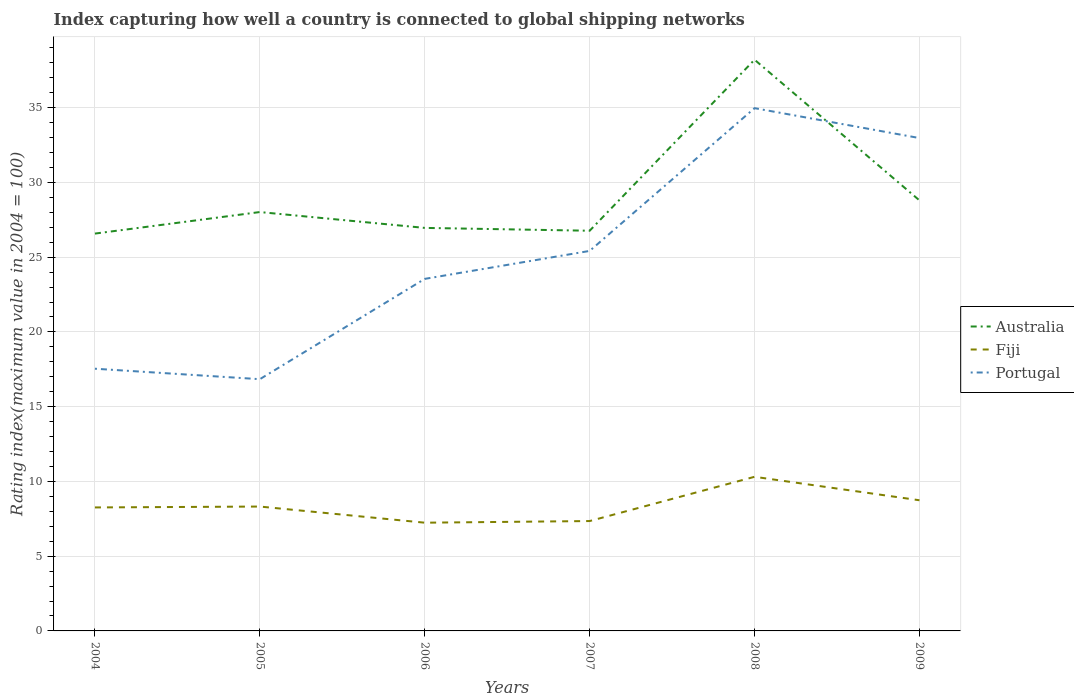Does the line corresponding to Australia intersect with the line corresponding to Portugal?
Give a very brief answer. Yes. Is the number of lines equal to the number of legend labels?
Keep it short and to the point. Yes. Across all years, what is the maximum rating index in Australia?
Provide a succinct answer. 26.58. What is the total rating index in Portugal in the graph?
Ensure brevity in your answer.  2. What is the difference between the highest and the second highest rating index in Fiji?
Give a very brief answer. 3.07. Is the rating index in Australia strictly greater than the rating index in Portugal over the years?
Ensure brevity in your answer.  No. How many years are there in the graph?
Keep it short and to the point. 6. Does the graph contain grids?
Your answer should be very brief. Yes. Where does the legend appear in the graph?
Make the answer very short. Center right. How are the legend labels stacked?
Provide a short and direct response. Vertical. What is the title of the graph?
Ensure brevity in your answer.  Index capturing how well a country is connected to global shipping networks. Does "Timor-Leste" appear as one of the legend labels in the graph?
Ensure brevity in your answer.  No. What is the label or title of the Y-axis?
Offer a very short reply. Rating index(maximum value in 2004 = 100). What is the Rating index(maximum value in 2004 = 100) of Australia in 2004?
Ensure brevity in your answer.  26.58. What is the Rating index(maximum value in 2004 = 100) in Fiji in 2004?
Provide a succinct answer. 8.26. What is the Rating index(maximum value in 2004 = 100) in Portugal in 2004?
Make the answer very short. 17.54. What is the Rating index(maximum value in 2004 = 100) of Australia in 2005?
Give a very brief answer. 28.02. What is the Rating index(maximum value in 2004 = 100) in Fiji in 2005?
Give a very brief answer. 8.32. What is the Rating index(maximum value in 2004 = 100) of Portugal in 2005?
Your response must be concise. 16.84. What is the Rating index(maximum value in 2004 = 100) in Australia in 2006?
Give a very brief answer. 26.96. What is the Rating index(maximum value in 2004 = 100) in Fiji in 2006?
Offer a very short reply. 7.24. What is the Rating index(maximum value in 2004 = 100) of Portugal in 2006?
Keep it short and to the point. 23.55. What is the Rating index(maximum value in 2004 = 100) in Australia in 2007?
Offer a terse response. 26.77. What is the Rating index(maximum value in 2004 = 100) of Fiji in 2007?
Provide a succinct answer. 7.35. What is the Rating index(maximum value in 2004 = 100) of Portugal in 2007?
Your answer should be compact. 25.42. What is the Rating index(maximum value in 2004 = 100) of Australia in 2008?
Make the answer very short. 38.21. What is the Rating index(maximum value in 2004 = 100) of Fiji in 2008?
Keep it short and to the point. 10.31. What is the Rating index(maximum value in 2004 = 100) in Portugal in 2008?
Ensure brevity in your answer.  34.97. What is the Rating index(maximum value in 2004 = 100) of Australia in 2009?
Offer a very short reply. 28.8. What is the Rating index(maximum value in 2004 = 100) in Fiji in 2009?
Make the answer very short. 8.74. What is the Rating index(maximum value in 2004 = 100) of Portugal in 2009?
Offer a terse response. 32.97. Across all years, what is the maximum Rating index(maximum value in 2004 = 100) of Australia?
Your answer should be very brief. 38.21. Across all years, what is the maximum Rating index(maximum value in 2004 = 100) in Fiji?
Your answer should be compact. 10.31. Across all years, what is the maximum Rating index(maximum value in 2004 = 100) in Portugal?
Provide a short and direct response. 34.97. Across all years, what is the minimum Rating index(maximum value in 2004 = 100) of Australia?
Offer a very short reply. 26.58. Across all years, what is the minimum Rating index(maximum value in 2004 = 100) of Fiji?
Offer a terse response. 7.24. Across all years, what is the minimum Rating index(maximum value in 2004 = 100) of Portugal?
Your response must be concise. 16.84. What is the total Rating index(maximum value in 2004 = 100) in Australia in the graph?
Keep it short and to the point. 175.34. What is the total Rating index(maximum value in 2004 = 100) in Fiji in the graph?
Provide a short and direct response. 50.22. What is the total Rating index(maximum value in 2004 = 100) in Portugal in the graph?
Offer a very short reply. 151.29. What is the difference between the Rating index(maximum value in 2004 = 100) in Australia in 2004 and that in 2005?
Your answer should be compact. -1.44. What is the difference between the Rating index(maximum value in 2004 = 100) in Fiji in 2004 and that in 2005?
Make the answer very short. -0.06. What is the difference between the Rating index(maximum value in 2004 = 100) in Portugal in 2004 and that in 2005?
Your answer should be compact. 0.7. What is the difference between the Rating index(maximum value in 2004 = 100) of Australia in 2004 and that in 2006?
Provide a succinct answer. -0.38. What is the difference between the Rating index(maximum value in 2004 = 100) of Portugal in 2004 and that in 2006?
Offer a very short reply. -6.01. What is the difference between the Rating index(maximum value in 2004 = 100) in Australia in 2004 and that in 2007?
Provide a short and direct response. -0.19. What is the difference between the Rating index(maximum value in 2004 = 100) in Fiji in 2004 and that in 2007?
Your answer should be compact. 0.91. What is the difference between the Rating index(maximum value in 2004 = 100) of Portugal in 2004 and that in 2007?
Provide a short and direct response. -7.88. What is the difference between the Rating index(maximum value in 2004 = 100) in Australia in 2004 and that in 2008?
Offer a very short reply. -11.63. What is the difference between the Rating index(maximum value in 2004 = 100) in Fiji in 2004 and that in 2008?
Keep it short and to the point. -2.05. What is the difference between the Rating index(maximum value in 2004 = 100) in Portugal in 2004 and that in 2008?
Keep it short and to the point. -17.43. What is the difference between the Rating index(maximum value in 2004 = 100) in Australia in 2004 and that in 2009?
Your answer should be compact. -2.22. What is the difference between the Rating index(maximum value in 2004 = 100) in Fiji in 2004 and that in 2009?
Offer a terse response. -0.48. What is the difference between the Rating index(maximum value in 2004 = 100) of Portugal in 2004 and that in 2009?
Offer a terse response. -15.43. What is the difference between the Rating index(maximum value in 2004 = 100) in Australia in 2005 and that in 2006?
Offer a terse response. 1.06. What is the difference between the Rating index(maximum value in 2004 = 100) in Fiji in 2005 and that in 2006?
Provide a short and direct response. 1.08. What is the difference between the Rating index(maximum value in 2004 = 100) in Portugal in 2005 and that in 2006?
Provide a succinct answer. -6.71. What is the difference between the Rating index(maximum value in 2004 = 100) in Portugal in 2005 and that in 2007?
Ensure brevity in your answer.  -8.58. What is the difference between the Rating index(maximum value in 2004 = 100) of Australia in 2005 and that in 2008?
Your answer should be very brief. -10.19. What is the difference between the Rating index(maximum value in 2004 = 100) in Fiji in 2005 and that in 2008?
Ensure brevity in your answer.  -1.99. What is the difference between the Rating index(maximum value in 2004 = 100) in Portugal in 2005 and that in 2008?
Offer a terse response. -18.13. What is the difference between the Rating index(maximum value in 2004 = 100) of Australia in 2005 and that in 2009?
Keep it short and to the point. -0.78. What is the difference between the Rating index(maximum value in 2004 = 100) of Fiji in 2005 and that in 2009?
Your answer should be compact. -0.42. What is the difference between the Rating index(maximum value in 2004 = 100) of Portugal in 2005 and that in 2009?
Offer a terse response. -16.13. What is the difference between the Rating index(maximum value in 2004 = 100) in Australia in 2006 and that in 2007?
Offer a very short reply. 0.19. What is the difference between the Rating index(maximum value in 2004 = 100) in Fiji in 2006 and that in 2007?
Provide a short and direct response. -0.11. What is the difference between the Rating index(maximum value in 2004 = 100) of Portugal in 2006 and that in 2007?
Keep it short and to the point. -1.87. What is the difference between the Rating index(maximum value in 2004 = 100) of Australia in 2006 and that in 2008?
Give a very brief answer. -11.25. What is the difference between the Rating index(maximum value in 2004 = 100) in Fiji in 2006 and that in 2008?
Ensure brevity in your answer.  -3.07. What is the difference between the Rating index(maximum value in 2004 = 100) in Portugal in 2006 and that in 2008?
Your answer should be very brief. -11.42. What is the difference between the Rating index(maximum value in 2004 = 100) of Australia in 2006 and that in 2009?
Ensure brevity in your answer.  -1.84. What is the difference between the Rating index(maximum value in 2004 = 100) of Fiji in 2006 and that in 2009?
Offer a terse response. -1.5. What is the difference between the Rating index(maximum value in 2004 = 100) of Portugal in 2006 and that in 2009?
Offer a very short reply. -9.42. What is the difference between the Rating index(maximum value in 2004 = 100) of Australia in 2007 and that in 2008?
Ensure brevity in your answer.  -11.44. What is the difference between the Rating index(maximum value in 2004 = 100) of Fiji in 2007 and that in 2008?
Make the answer very short. -2.96. What is the difference between the Rating index(maximum value in 2004 = 100) in Portugal in 2007 and that in 2008?
Your response must be concise. -9.55. What is the difference between the Rating index(maximum value in 2004 = 100) in Australia in 2007 and that in 2009?
Provide a short and direct response. -2.03. What is the difference between the Rating index(maximum value in 2004 = 100) of Fiji in 2007 and that in 2009?
Offer a terse response. -1.39. What is the difference between the Rating index(maximum value in 2004 = 100) of Portugal in 2007 and that in 2009?
Ensure brevity in your answer.  -7.55. What is the difference between the Rating index(maximum value in 2004 = 100) of Australia in 2008 and that in 2009?
Ensure brevity in your answer.  9.41. What is the difference between the Rating index(maximum value in 2004 = 100) in Fiji in 2008 and that in 2009?
Your response must be concise. 1.57. What is the difference between the Rating index(maximum value in 2004 = 100) of Portugal in 2008 and that in 2009?
Make the answer very short. 2. What is the difference between the Rating index(maximum value in 2004 = 100) of Australia in 2004 and the Rating index(maximum value in 2004 = 100) of Fiji in 2005?
Ensure brevity in your answer.  18.26. What is the difference between the Rating index(maximum value in 2004 = 100) of Australia in 2004 and the Rating index(maximum value in 2004 = 100) of Portugal in 2005?
Your answer should be very brief. 9.74. What is the difference between the Rating index(maximum value in 2004 = 100) of Fiji in 2004 and the Rating index(maximum value in 2004 = 100) of Portugal in 2005?
Provide a succinct answer. -8.58. What is the difference between the Rating index(maximum value in 2004 = 100) in Australia in 2004 and the Rating index(maximum value in 2004 = 100) in Fiji in 2006?
Give a very brief answer. 19.34. What is the difference between the Rating index(maximum value in 2004 = 100) of Australia in 2004 and the Rating index(maximum value in 2004 = 100) of Portugal in 2006?
Give a very brief answer. 3.03. What is the difference between the Rating index(maximum value in 2004 = 100) of Fiji in 2004 and the Rating index(maximum value in 2004 = 100) of Portugal in 2006?
Offer a terse response. -15.29. What is the difference between the Rating index(maximum value in 2004 = 100) of Australia in 2004 and the Rating index(maximum value in 2004 = 100) of Fiji in 2007?
Offer a terse response. 19.23. What is the difference between the Rating index(maximum value in 2004 = 100) of Australia in 2004 and the Rating index(maximum value in 2004 = 100) of Portugal in 2007?
Give a very brief answer. 1.16. What is the difference between the Rating index(maximum value in 2004 = 100) in Fiji in 2004 and the Rating index(maximum value in 2004 = 100) in Portugal in 2007?
Offer a terse response. -17.16. What is the difference between the Rating index(maximum value in 2004 = 100) in Australia in 2004 and the Rating index(maximum value in 2004 = 100) in Fiji in 2008?
Offer a terse response. 16.27. What is the difference between the Rating index(maximum value in 2004 = 100) in Australia in 2004 and the Rating index(maximum value in 2004 = 100) in Portugal in 2008?
Ensure brevity in your answer.  -8.39. What is the difference between the Rating index(maximum value in 2004 = 100) of Fiji in 2004 and the Rating index(maximum value in 2004 = 100) of Portugal in 2008?
Offer a terse response. -26.71. What is the difference between the Rating index(maximum value in 2004 = 100) of Australia in 2004 and the Rating index(maximum value in 2004 = 100) of Fiji in 2009?
Provide a succinct answer. 17.84. What is the difference between the Rating index(maximum value in 2004 = 100) of Australia in 2004 and the Rating index(maximum value in 2004 = 100) of Portugal in 2009?
Your answer should be compact. -6.39. What is the difference between the Rating index(maximum value in 2004 = 100) of Fiji in 2004 and the Rating index(maximum value in 2004 = 100) of Portugal in 2009?
Offer a terse response. -24.71. What is the difference between the Rating index(maximum value in 2004 = 100) of Australia in 2005 and the Rating index(maximum value in 2004 = 100) of Fiji in 2006?
Your answer should be very brief. 20.78. What is the difference between the Rating index(maximum value in 2004 = 100) of Australia in 2005 and the Rating index(maximum value in 2004 = 100) of Portugal in 2006?
Give a very brief answer. 4.47. What is the difference between the Rating index(maximum value in 2004 = 100) in Fiji in 2005 and the Rating index(maximum value in 2004 = 100) in Portugal in 2006?
Ensure brevity in your answer.  -15.23. What is the difference between the Rating index(maximum value in 2004 = 100) of Australia in 2005 and the Rating index(maximum value in 2004 = 100) of Fiji in 2007?
Your response must be concise. 20.67. What is the difference between the Rating index(maximum value in 2004 = 100) in Fiji in 2005 and the Rating index(maximum value in 2004 = 100) in Portugal in 2007?
Keep it short and to the point. -17.1. What is the difference between the Rating index(maximum value in 2004 = 100) of Australia in 2005 and the Rating index(maximum value in 2004 = 100) of Fiji in 2008?
Keep it short and to the point. 17.71. What is the difference between the Rating index(maximum value in 2004 = 100) of Australia in 2005 and the Rating index(maximum value in 2004 = 100) of Portugal in 2008?
Your answer should be compact. -6.95. What is the difference between the Rating index(maximum value in 2004 = 100) in Fiji in 2005 and the Rating index(maximum value in 2004 = 100) in Portugal in 2008?
Your answer should be compact. -26.65. What is the difference between the Rating index(maximum value in 2004 = 100) in Australia in 2005 and the Rating index(maximum value in 2004 = 100) in Fiji in 2009?
Your answer should be very brief. 19.28. What is the difference between the Rating index(maximum value in 2004 = 100) in Australia in 2005 and the Rating index(maximum value in 2004 = 100) in Portugal in 2009?
Provide a short and direct response. -4.95. What is the difference between the Rating index(maximum value in 2004 = 100) in Fiji in 2005 and the Rating index(maximum value in 2004 = 100) in Portugal in 2009?
Your answer should be very brief. -24.65. What is the difference between the Rating index(maximum value in 2004 = 100) of Australia in 2006 and the Rating index(maximum value in 2004 = 100) of Fiji in 2007?
Your answer should be very brief. 19.61. What is the difference between the Rating index(maximum value in 2004 = 100) of Australia in 2006 and the Rating index(maximum value in 2004 = 100) of Portugal in 2007?
Your answer should be very brief. 1.54. What is the difference between the Rating index(maximum value in 2004 = 100) of Fiji in 2006 and the Rating index(maximum value in 2004 = 100) of Portugal in 2007?
Make the answer very short. -18.18. What is the difference between the Rating index(maximum value in 2004 = 100) in Australia in 2006 and the Rating index(maximum value in 2004 = 100) in Fiji in 2008?
Your answer should be compact. 16.65. What is the difference between the Rating index(maximum value in 2004 = 100) of Australia in 2006 and the Rating index(maximum value in 2004 = 100) of Portugal in 2008?
Keep it short and to the point. -8.01. What is the difference between the Rating index(maximum value in 2004 = 100) in Fiji in 2006 and the Rating index(maximum value in 2004 = 100) in Portugal in 2008?
Make the answer very short. -27.73. What is the difference between the Rating index(maximum value in 2004 = 100) of Australia in 2006 and the Rating index(maximum value in 2004 = 100) of Fiji in 2009?
Your answer should be very brief. 18.22. What is the difference between the Rating index(maximum value in 2004 = 100) of Australia in 2006 and the Rating index(maximum value in 2004 = 100) of Portugal in 2009?
Give a very brief answer. -6.01. What is the difference between the Rating index(maximum value in 2004 = 100) of Fiji in 2006 and the Rating index(maximum value in 2004 = 100) of Portugal in 2009?
Your answer should be compact. -25.73. What is the difference between the Rating index(maximum value in 2004 = 100) of Australia in 2007 and the Rating index(maximum value in 2004 = 100) of Fiji in 2008?
Give a very brief answer. 16.46. What is the difference between the Rating index(maximum value in 2004 = 100) of Fiji in 2007 and the Rating index(maximum value in 2004 = 100) of Portugal in 2008?
Offer a very short reply. -27.62. What is the difference between the Rating index(maximum value in 2004 = 100) in Australia in 2007 and the Rating index(maximum value in 2004 = 100) in Fiji in 2009?
Provide a short and direct response. 18.03. What is the difference between the Rating index(maximum value in 2004 = 100) of Australia in 2007 and the Rating index(maximum value in 2004 = 100) of Portugal in 2009?
Ensure brevity in your answer.  -6.2. What is the difference between the Rating index(maximum value in 2004 = 100) of Fiji in 2007 and the Rating index(maximum value in 2004 = 100) of Portugal in 2009?
Keep it short and to the point. -25.62. What is the difference between the Rating index(maximum value in 2004 = 100) of Australia in 2008 and the Rating index(maximum value in 2004 = 100) of Fiji in 2009?
Your answer should be compact. 29.47. What is the difference between the Rating index(maximum value in 2004 = 100) in Australia in 2008 and the Rating index(maximum value in 2004 = 100) in Portugal in 2009?
Make the answer very short. 5.24. What is the difference between the Rating index(maximum value in 2004 = 100) of Fiji in 2008 and the Rating index(maximum value in 2004 = 100) of Portugal in 2009?
Offer a terse response. -22.66. What is the average Rating index(maximum value in 2004 = 100) in Australia per year?
Provide a succinct answer. 29.22. What is the average Rating index(maximum value in 2004 = 100) in Fiji per year?
Give a very brief answer. 8.37. What is the average Rating index(maximum value in 2004 = 100) in Portugal per year?
Provide a succinct answer. 25.21. In the year 2004, what is the difference between the Rating index(maximum value in 2004 = 100) in Australia and Rating index(maximum value in 2004 = 100) in Fiji?
Your response must be concise. 18.32. In the year 2004, what is the difference between the Rating index(maximum value in 2004 = 100) of Australia and Rating index(maximum value in 2004 = 100) of Portugal?
Your answer should be very brief. 9.04. In the year 2004, what is the difference between the Rating index(maximum value in 2004 = 100) in Fiji and Rating index(maximum value in 2004 = 100) in Portugal?
Keep it short and to the point. -9.28. In the year 2005, what is the difference between the Rating index(maximum value in 2004 = 100) of Australia and Rating index(maximum value in 2004 = 100) of Portugal?
Offer a terse response. 11.18. In the year 2005, what is the difference between the Rating index(maximum value in 2004 = 100) of Fiji and Rating index(maximum value in 2004 = 100) of Portugal?
Offer a very short reply. -8.52. In the year 2006, what is the difference between the Rating index(maximum value in 2004 = 100) of Australia and Rating index(maximum value in 2004 = 100) of Fiji?
Ensure brevity in your answer.  19.72. In the year 2006, what is the difference between the Rating index(maximum value in 2004 = 100) in Australia and Rating index(maximum value in 2004 = 100) in Portugal?
Your answer should be very brief. 3.41. In the year 2006, what is the difference between the Rating index(maximum value in 2004 = 100) in Fiji and Rating index(maximum value in 2004 = 100) in Portugal?
Provide a short and direct response. -16.31. In the year 2007, what is the difference between the Rating index(maximum value in 2004 = 100) in Australia and Rating index(maximum value in 2004 = 100) in Fiji?
Make the answer very short. 19.42. In the year 2007, what is the difference between the Rating index(maximum value in 2004 = 100) of Australia and Rating index(maximum value in 2004 = 100) of Portugal?
Make the answer very short. 1.35. In the year 2007, what is the difference between the Rating index(maximum value in 2004 = 100) in Fiji and Rating index(maximum value in 2004 = 100) in Portugal?
Keep it short and to the point. -18.07. In the year 2008, what is the difference between the Rating index(maximum value in 2004 = 100) of Australia and Rating index(maximum value in 2004 = 100) of Fiji?
Your response must be concise. 27.9. In the year 2008, what is the difference between the Rating index(maximum value in 2004 = 100) in Australia and Rating index(maximum value in 2004 = 100) in Portugal?
Make the answer very short. 3.24. In the year 2008, what is the difference between the Rating index(maximum value in 2004 = 100) of Fiji and Rating index(maximum value in 2004 = 100) of Portugal?
Your answer should be very brief. -24.66. In the year 2009, what is the difference between the Rating index(maximum value in 2004 = 100) in Australia and Rating index(maximum value in 2004 = 100) in Fiji?
Offer a very short reply. 20.06. In the year 2009, what is the difference between the Rating index(maximum value in 2004 = 100) of Australia and Rating index(maximum value in 2004 = 100) of Portugal?
Provide a short and direct response. -4.17. In the year 2009, what is the difference between the Rating index(maximum value in 2004 = 100) of Fiji and Rating index(maximum value in 2004 = 100) of Portugal?
Your answer should be very brief. -24.23. What is the ratio of the Rating index(maximum value in 2004 = 100) in Australia in 2004 to that in 2005?
Offer a terse response. 0.95. What is the ratio of the Rating index(maximum value in 2004 = 100) in Portugal in 2004 to that in 2005?
Give a very brief answer. 1.04. What is the ratio of the Rating index(maximum value in 2004 = 100) of Australia in 2004 to that in 2006?
Provide a short and direct response. 0.99. What is the ratio of the Rating index(maximum value in 2004 = 100) in Fiji in 2004 to that in 2006?
Provide a succinct answer. 1.14. What is the ratio of the Rating index(maximum value in 2004 = 100) in Portugal in 2004 to that in 2006?
Your answer should be very brief. 0.74. What is the ratio of the Rating index(maximum value in 2004 = 100) of Australia in 2004 to that in 2007?
Offer a very short reply. 0.99. What is the ratio of the Rating index(maximum value in 2004 = 100) of Fiji in 2004 to that in 2007?
Your response must be concise. 1.12. What is the ratio of the Rating index(maximum value in 2004 = 100) of Portugal in 2004 to that in 2007?
Your answer should be compact. 0.69. What is the ratio of the Rating index(maximum value in 2004 = 100) in Australia in 2004 to that in 2008?
Make the answer very short. 0.7. What is the ratio of the Rating index(maximum value in 2004 = 100) of Fiji in 2004 to that in 2008?
Keep it short and to the point. 0.8. What is the ratio of the Rating index(maximum value in 2004 = 100) of Portugal in 2004 to that in 2008?
Provide a succinct answer. 0.5. What is the ratio of the Rating index(maximum value in 2004 = 100) in Australia in 2004 to that in 2009?
Offer a very short reply. 0.92. What is the ratio of the Rating index(maximum value in 2004 = 100) of Fiji in 2004 to that in 2009?
Ensure brevity in your answer.  0.95. What is the ratio of the Rating index(maximum value in 2004 = 100) in Portugal in 2004 to that in 2009?
Keep it short and to the point. 0.53. What is the ratio of the Rating index(maximum value in 2004 = 100) of Australia in 2005 to that in 2006?
Keep it short and to the point. 1.04. What is the ratio of the Rating index(maximum value in 2004 = 100) of Fiji in 2005 to that in 2006?
Your answer should be very brief. 1.15. What is the ratio of the Rating index(maximum value in 2004 = 100) of Portugal in 2005 to that in 2006?
Provide a succinct answer. 0.72. What is the ratio of the Rating index(maximum value in 2004 = 100) of Australia in 2005 to that in 2007?
Your answer should be very brief. 1.05. What is the ratio of the Rating index(maximum value in 2004 = 100) of Fiji in 2005 to that in 2007?
Your answer should be compact. 1.13. What is the ratio of the Rating index(maximum value in 2004 = 100) in Portugal in 2005 to that in 2007?
Provide a succinct answer. 0.66. What is the ratio of the Rating index(maximum value in 2004 = 100) of Australia in 2005 to that in 2008?
Make the answer very short. 0.73. What is the ratio of the Rating index(maximum value in 2004 = 100) in Fiji in 2005 to that in 2008?
Ensure brevity in your answer.  0.81. What is the ratio of the Rating index(maximum value in 2004 = 100) of Portugal in 2005 to that in 2008?
Provide a succinct answer. 0.48. What is the ratio of the Rating index(maximum value in 2004 = 100) in Australia in 2005 to that in 2009?
Keep it short and to the point. 0.97. What is the ratio of the Rating index(maximum value in 2004 = 100) in Fiji in 2005 to that in 2009?
Keep it short and to the point. 0.95. What is the ratio of the Rating index(maximum value in 2004 = 100) of Portugal in 2005 to that in 2009?
Make the answer very short. 0.51. What is the ratio of the Rating index(maximum value in 2004 = 100) in Australia in 2006 to that in 2007?
Ensure brevity in your answer.  1.01. What is the ratio of the Rating index(maximum value in 2004 = 100) of Fiji in 2006 to that in 2007?
Provide a succinct answer. 0.98. What is the ratio of the Rating index(maximum value in 2004 = 100) in Portugal in 2006 to that in 2007?
Provide a succinct answer. 0.93. What is the ratio of the Rating index(maximum value in 2004 = 100) of Australia in 2006 to that in 2008?
Your response must be concise. 0.71. What is the ratio of the Rating index(maximum value in 2004 = 100) of Fiji in 2006 to that in 2008?
Your answer should be very brief. 0.7. What is the ratio of the Rating index(maximum value in 2004 = 100) of Portugal in 2006 to that in 2008?
Make the answer very short. 0.67. What is the ratio of the Rating index(maximum value in 2004 = 100) of Australia in 2006 to that in 2009?
Offer a very short reply. 0.94. What is the ratio of the Rating index(maximum value in 2004 = 100) of Fiji in 2006 to that in 2009?
Offer a terse response. 0.83. What is the ratio of the Rating index(maximum value in 2004 = 100) in Australia in 2007 to that in 2008?
Your answer should be very brief. 0.7. What is the ratio of the Rating index(maximum value in 2004 = 100) of Fiji in 2007 to that in 2008?
Your answer should be compact. 0.71. What is the ratio of the Rating index(maximum value in 2004 = 100) of Portugal in 2007 to that in 2008?
Make the answer very short. 0.73. What is the ratio of the Rating index(maximum value in 2004 = 100) in Australia in 2007 to that in 2009?
Give a very brief answer. 0.93. What is the ratio of the Rating index(maximum value in 2004 = 100) of Fiji in 2007 to that in 2009?
Provide a succinct answer. 0.84. What is the ratio of the Rating index(maximum value in 2004 = 100) in Portugal in 2007 to that in 2009?
Keep it short and to the point. 0.77. What is the ratio of the Rating index(maximum value in 2004 = 100) of Australia in 2008 to that in 2009?
Provide a succinct answer. 1.33. What is the ratio of the Rating index(maximum value in 2004 = 100) in Fiji in 2008 to that in 2009?
Make the answer very short. 1.18. What is the ratio of the Rating index(maximum value in 2004 = 100) of Portugal in 2008 to that in 2009?
Ensure brevity in your answer.  1.06. What is the difference between the highest and the second highest Rating index(maximum value in 2004 = 100) in Australia?
Your answer should be very brief. 9.41. What is the difference between the highest and the second highest Rating index(maximum value in 2004 = 100) of Fiji?
Ensure brevity in your answer.  1.57. What is the difference between the highest and the second highest Rating index(maximum value in 2004 = 100) in Portugal?
Your answer should be compact. 2. What is the difference between the highest and the lowest Rating index(maximum value in 2004 = 100) of Australia?
Keep it short and to the point. 11.63. What is the difference between the highest and the lowest Rating index(maximum value in 2004 = 100) in Fiji?
Make the answer very short. 3.07. What is the difference between the highest and the lowest Rating index(maximum value in 2004 = 100) of Portugal?
Make the answer very short. 18.13. 